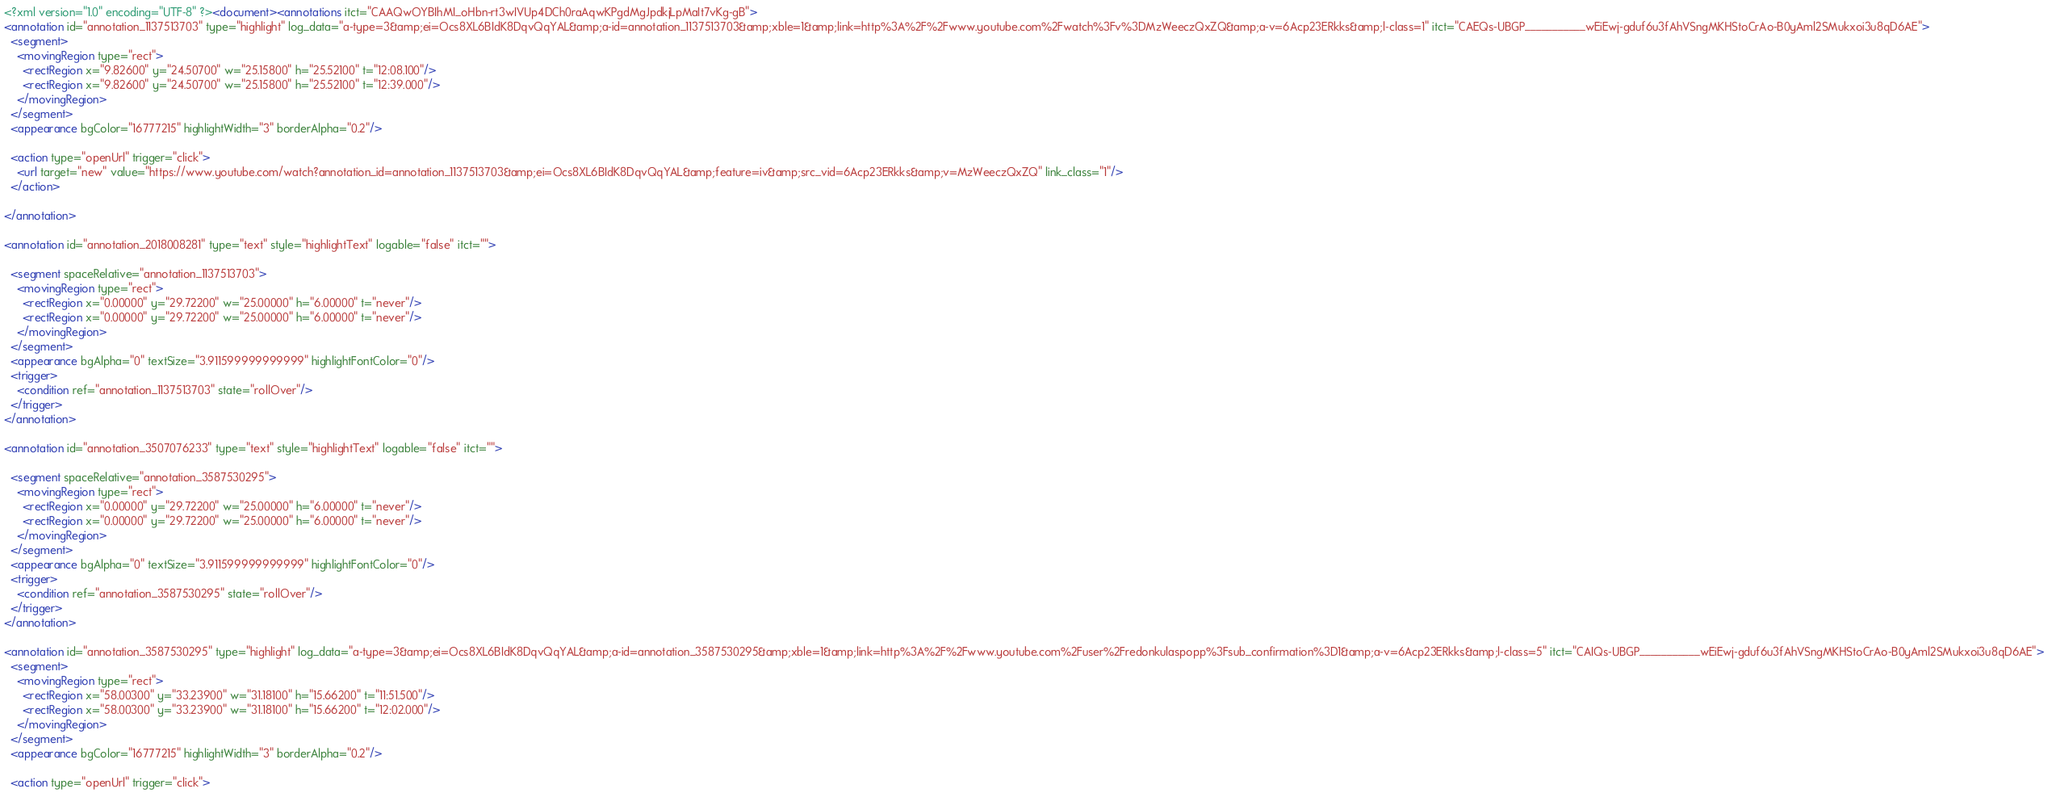Convert code to text. <code><loc_0><loc_0><loc_500><loc_500><_XML_><?xml version="1.0" encoding="UTF-8" ?><document><annotations itct="CAAQwOYBIhMI_oHbn-rt3wIVUp4DCh0raAqwKPgdMgJpdkjLpMaIt7vKg-gB">
<annotation id="annotation_1137513703" type="highlight" log_data="a-type=3&amp;ei=Ocs8XL6BIdK8DqvQqYAL&amp;a-id=annotation_1137513703&amp;xble=1&amp;link=http%3A%2F%2Fwww.youtube.com%2Fwatch%3Fv%3DMzWeeczQxZQ&amp;a-v=6Acp23ERkks&amp;l-class=1" itct="CAEQs-UBGP___________wEiEwj-gduf6u3fAhVSngMKHStoCrAo-B0yAml2SMukxoi3u8qD6AE">
  <segment>
    <movingRegion type="rect">
      <rectRegion x="9.82600" y="24.50700" w="25.15800" h="25.52100" t="12:08.100"/>
      <rectRegion x="9.82600" y="24.50700" w="25.15800" h="25.52100" t="12:39.000"/>
    </movingRegion>
  </segment>
  <appearance bgColor="16777215" highlightWidth="3" borderAlpha="0.2"/>
  
  <action type="openUrl" trigger="click">
    <url target="new" value="https://www.youtube.com/watch?annotation_id=annotation_1137513703&amp;ei=Ocs8XL6BIdK8DqvQqYAL&amp;feature=iv&amp;src_vid=6Acp23ERkks&amp;v=MzWeeczQxZQ" link_class="1"/>
  </action>

</annotation>

<annotation id="annotation_2018008281" type="text" style="highlightText" logable="false" itct="">
  
  <segment spaceRelative="annotation_1137513703">
    <movingRegion type="rect">
      <rectRegion x="0.00000" y="29.72200" w="25.00000" h="6.00000" t="never"/>
      <rectRegion x="0.00000" y="29.72200" w="25.00000" h="6.00000" t="never"/>
    </movingRegion>
  </segment>
  <appearance bgAlpha="0" textSize="3.911599999999999" highlightFontColor="0"/>
  <trigger>
    <condition ref="annotation_1137513703" state="rollOver"/>
  </trigger>
</annotation>

<annotation id="annotation_3507076233" type="text" style="highlightText" logable="false" itct="">
  
  <segment spaceRelative="annotation_3587530295">
    <movingRegion type="rect">
      <rectRegion x="0.00000" y="29.72200" w="25.00000" h="6.00000" t="never"/>
      <rectRegion x="0.00000" y="29.72200" w="25.00000" h="6.00000" t="never"/>
    </movingRegion>
  </segment>
  <appearance bgAlpha="0" textSize="3.911599999999999" highlightFontColor="0"/>
  <trigger>
    <condition ref="annotation_3587530295" state="rollOver"/>
  </trigger>
</annotation>

<annotation id="annotation_3587530295" type="highlight" log_data="a-type=3&amp;ei=Ocs8XL6BIdK8DqvQqYAL&amp;a-id=annotation_3587530295&amp;xble=1&amp;link=http%3A%2F%2Fwww.youtube.com%2Fuser%2Fredonkulaspopp%3Fsub_confirmation%3D1&amp;a-v=6Acp23ERkks&amp;l-class=5" itct="CAIQs-UBGP___________wEiEwj-gduf6u3fAhVSngMKHStoCrAo-B0yAml2SMukxoi3u8qD6AE">
  <segment>
    <movingRegion type="rect">
      <rectRegion x="58.00300" y="33.23900" w="31.18100" h="15.66200" t="11:51.500"/>
      <rectRegion x="58.00300" y="33.23900" w="31.18100" h="15.66200" t="12:02.000"/>
    </movingRegion>
  </segment>
  <appearance bgColor="16777215" highlightWidth="3" borderAlpha="0.2"/>
  
  <action type="openUrl" trigger="click"></code> 